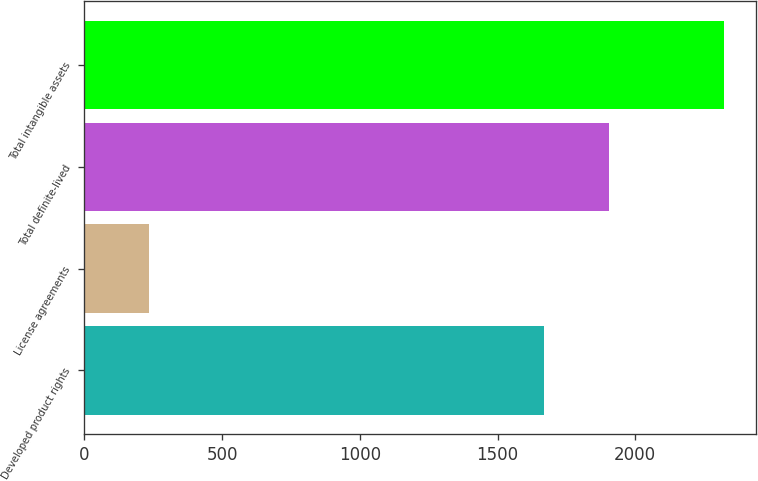Convert chart to OTSL. <chart><loc_0><loc_0><loc_500><loc_500><bar_chart><fcel>Developed product rights<fcel>License agreements<fcel>Total definite-lived<fcel>Total intangible assets<nl><fcel>1668<fcel>235<fcel>1903<fcel>2323<nl></chart> 